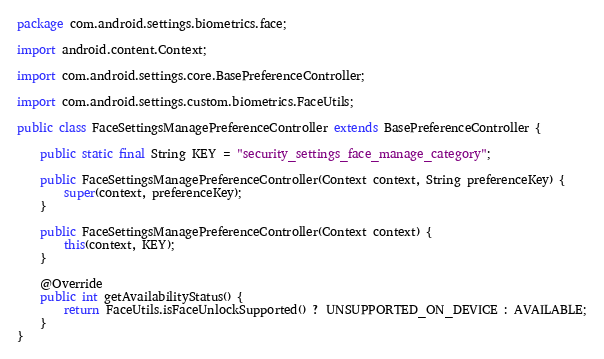Convert code to text. <code><loc_0><loc_0><loc_500><loc_500><_Java_>package com.android.settings.biometrics.face;

import android.content.Context;

import com.android.settings.core.BasePreferenceController;

import com.android.settings.custom.biometrics.FaceUtils;

public class FaceSettingsManagePreferenceController extends BasePreferenceController {

    public static final String KEY = "security_settings_face_manage_category";

    public FaceSettingsManagePreferenceController(Context context, String preferenceKey) {
        super(context, preferenceKey);
    }

    public FaceSettingsManagePreferenceController(Context context) {
        this(context, KEY);
    }

    @Override
    public int getAvailabilityStatus() {
        return FaceUtils.isFaceUnlockSupported() ? UNSUPPORTED_ON_DEVICE : AVAILABLE;
    }
}</code> 